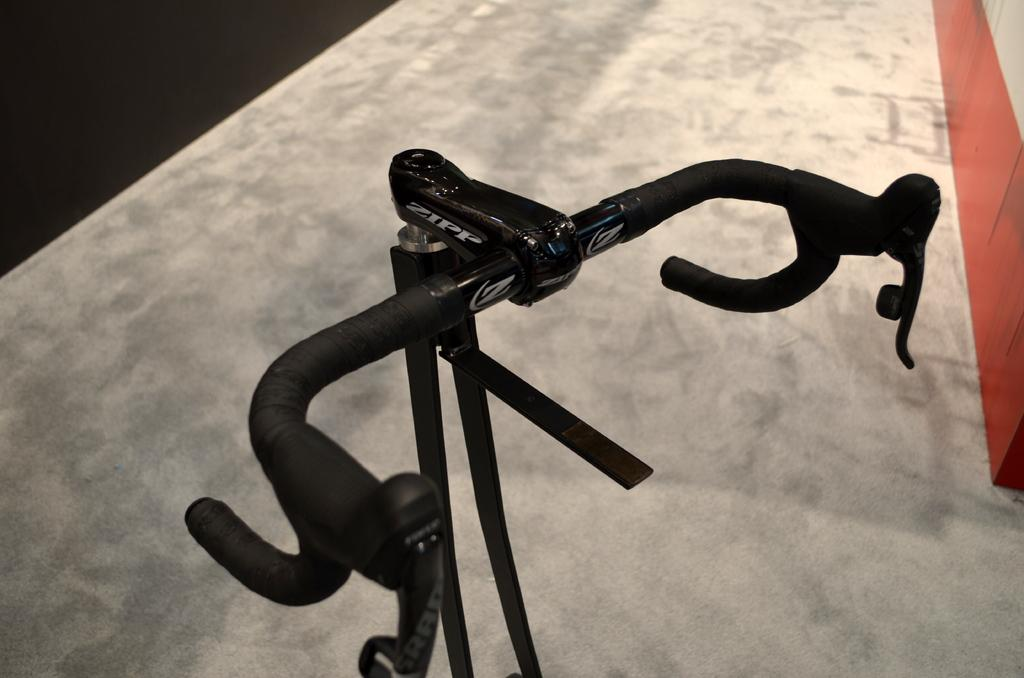What is the main subject in the foreground of the image? There is a handle of a bicycle in the foreground of the image. What type of cake is being served at the spring event in the image? There is no cake or spring event present in the image; it only features the handle of a bicycle. 